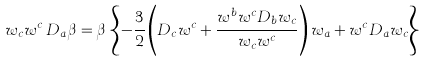<formula> <loc_0><loc_0><loc_500><loc_500>w _ { c } w ^ { c } \, D _ { a } \beta = \beta \, \left \{ - \frac { 3 } { 2 } \left ( D _ { c } w ^ { c } + \frac { w ^ { b } w ^ { c } D _ { b } w _ { c } } { w _ { c } w ^ { c } } \right ) w _ { a } + w ^ { c } D _ { a } w _ { c } \right \}</formula> 